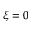<formula> <loc_0><loc_0><loc_500><loc_500>\xi = 0</formula> 